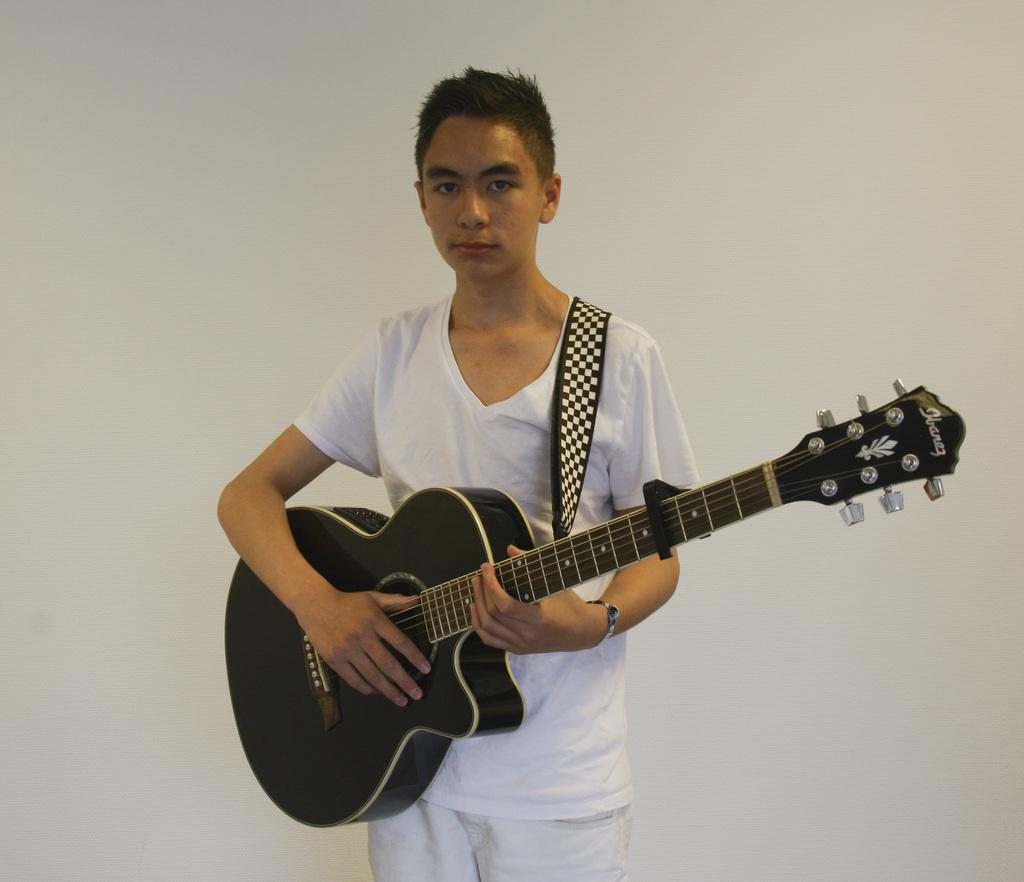What is the color of the wall in the background of the image? The wall in the background of the image is white-colored. What is the main subject of the image? There is a man in the image. What is the man wearing? The man is wearing a white-colored dress. What object is the man holding in the image? The man is holding a guitar in his hands. What type of coil is wrapped around the guitar in the image? There is no coil wrapped around the guitar in the image; the man is simply holding the guitar. What type of string is attached to the man's skin in the image? There is no string attached to the man's skin in the image; he is simply wearing a white-colored dress and holding a guitar. 